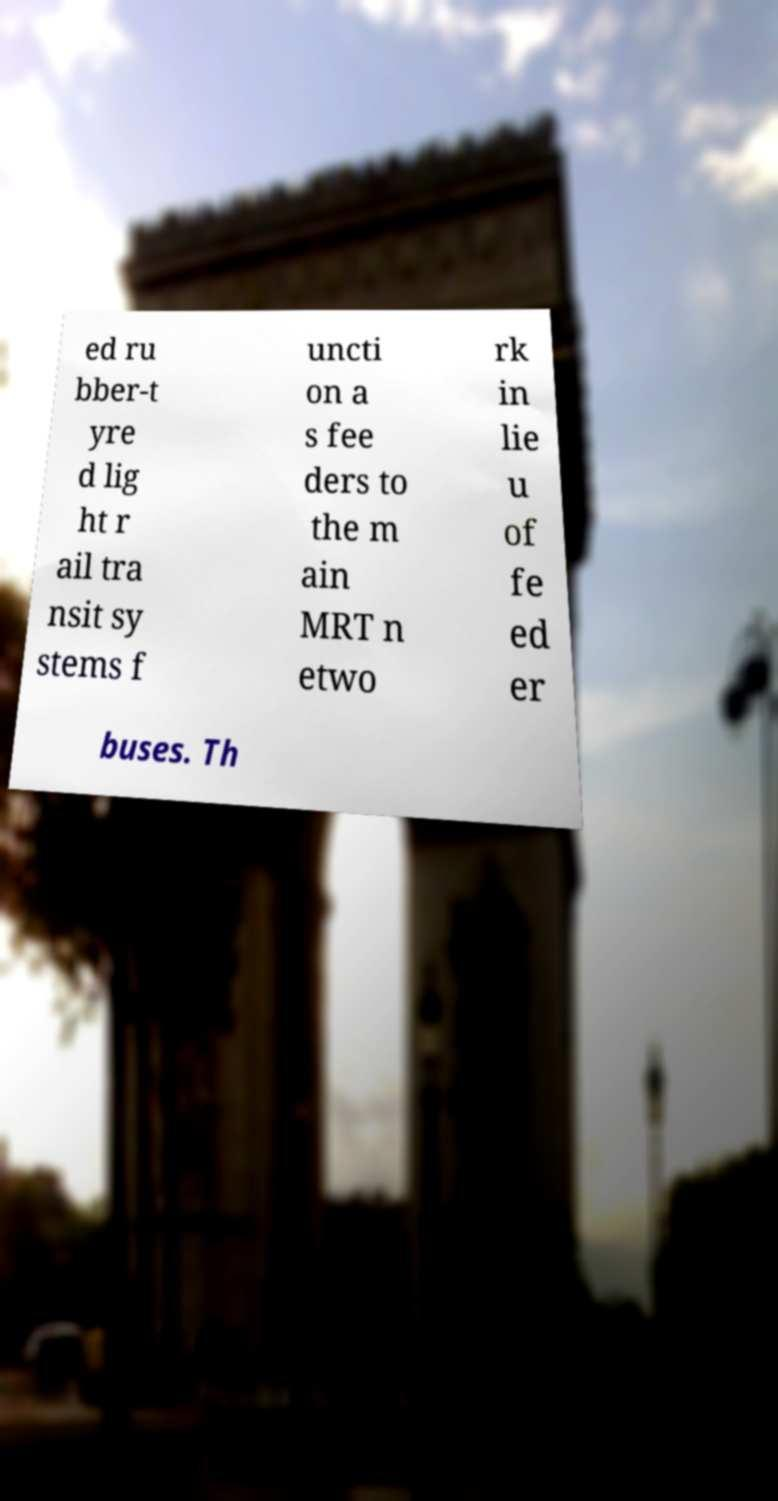Can you accurately transcribe the text from the provided image for me? ed ru bber-t yre d lig ht r ail tra nsit sy stems f uncti on a s fee ders to the m ain MRT n etwo rk in lie u of fe ed er buses. Th 